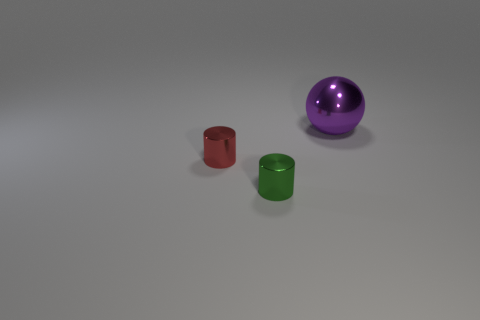Add 2 green metallic cylinders. How many objects exist? 5 Subtract all spheres. How many objects are left? 2 Subtract 0 purple cylinders. How many objects are left? 3 Subtract all small blue matte spheres. Subtract all green metal things. How many objects are left? 2 Add 1 small green things. How many small green things are left? 2 Add 1 large green metallic spheres. How many large green metallic spheres exist? 1 